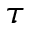Convert formula to latex. <formula><loc_0><loc_0><loc_500><loc_500>\tau</formula> 